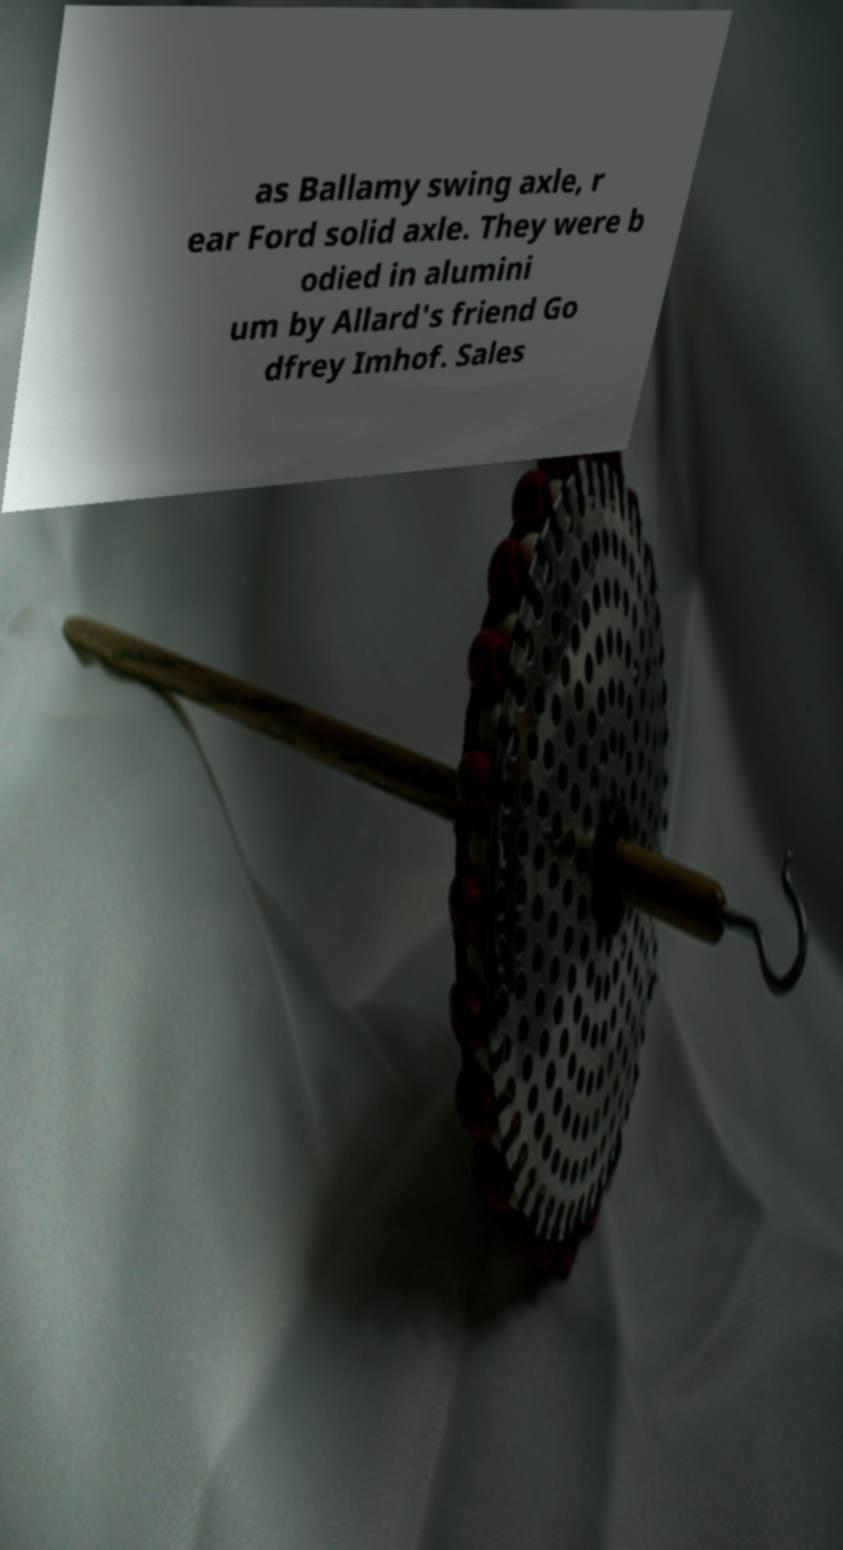There's text embedded in this image that I need extracted. Can you transcribe it verbatim? as Ballamy swing axle, r ear Ford solid axle. They were b odied in alumini um by Allard's friend Go dfrey Imhof. Sales 